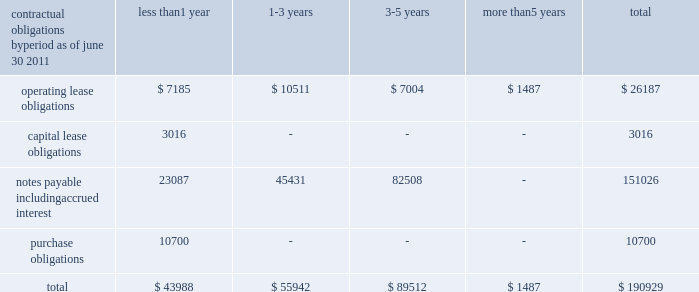Contractual obligations by less than more than period as of june 30 , 2011 1 year 1-3 years 3-5 years 5 years total .
Recent accounting pronouncements in october 2009 , the fasb issued accounting standards update ( 201casu 201d ) no .
2009-13 , multiple-deliverable revenue arrangements , which is effective for arrangements beginning or changed during fiscal years starting after june 15 , 2010 .
This new standard eliminates the use of the residual method of revenue recognition and requires the allocation of consideration to each deliverable using the relative selling price method .
This new guidance did not have a material impact on revenue recognition because nearly all of the company 2019s revenue arrangements are subject to accounting standards codification ( 201casc 201d ) topic 985 .
Such arrangements are considered out of scope for this asu .
In october 2009 , the fasb also issued asu no .
2009-14 , software : certain revenue arrangements that include software elements , which is also effective for arrangements beginning or changed during fiscal years starting after june 15 , 2010 .
This revision to software ( topic 985 ) drops from its scope all tangible products containing both software and non-software components that operate together to deliver the product 2019s functions .
The majority of the company 2019s software arrangements are not tangible products with software components ; therefore , this update did not materially impact the company .
The fasb issued asu no .
2011-04 , fair value measurement in may 2011 , which is effective for the company beginning july 1 , 2012 and is to be applied prospectively .
The updated explanatory guidance on measuring fair value will be adopted by the company at that time and is not expected to have a significant impact on our fair value calculations .
No additional fair value measurements are required as a result of the update .
The fasb also issued asu no .
2011-05 , comprehensive income in june 2011 , which is effective for the company beginning january 1 , 2012 and will be applied retrospectively .
The updated guidance requires non-owner changes in stockholders 2019 equity to be reported either in a single continuous statement of comprehensive income or in two separate but consecutive statements , rather than as part of the statement of changes in stockholders 2019 equity .
No changes in disclosure will be required as a result of the update .
Critical accounting policies we prepare our consolidated financial statements in accordance with accounting principles generally accepted in the united states ( 201cu.s .
Gaap 201d ) .
The significant accounting policies are discussed in note 1 to the consolidated financial statements .
The preparation of consolidated financial statements in accordance with u.s .
Gaap requires us to make estimates and judgments that affect the reported amounts of assets , liabilities , revenue and expenses , as well as disclosure of contingent assets and liabilities .
We base our estimates and judgments upon historical experience and other factors believed to be reasonable under the circumstances .
Changes in estimates or assumptions could result in a material adjustment to the consolidated financial statements .
We have identified several critical accounting estimates .
An accounting estimate is considered critical if both : ( a ) the nature of the estimates or assumptions is material due to the levels of subjectivity and judgment involved , and ( b ) the impact of changes in the estimates and assumptions would have a material effect on the consolidated financial statements. .
What was the percent of the total operating lease obligations that was due in less than 1 year? 
Computations: (7185 / 26187)
Answer: 0.27437. Contractual obligations by less than more than period as of june 30 , 2011 1 year 1-3 years 3-5 years 5 years total .
Recent accounting pronouncements in october 2009 , the fasb issued accounting standards update ( 201casu 201d ) no .
2009-13 , multiple-deliverable revenue arrangements , which is effective for arrangements beginning or changed during fiscal years starting after june 15 , 2010 .
This new standard eliminates the use of the residual method of revenue recognition and requires the allocation of consideration to each deliverable using the relative selling price method .
This new guidance did not have a material impact on revenue recognition because nearly all of the company 2019s revenue arrangements are subject to accounting standards codification ( 201casc 201d ) topic 985 .
Such arrangements are considered out of scope for this asu .
In october 2009 , the fasb also issued asu no .
2009-14 , software : certain revenue arrangements that include software elements , which is also effective for arrangements beginning or changed during fiscal years starting after june 15 , 2010 .
This revision to software ( topic 985 ) drops from its scope all tangible products containing both software and non-software components that operate together to deliver the product 2019s functions .
The majority of the company 2019s software arrangements are not tangible products with software components ; therefore , this update did not materially impact the company .
The fasb issued asu no .
2011-04 , fair value measurement in may 2011 , which is effective for the company beginning july 1 , 2012 and is to be applied prospectively .
The updated explanatory guidance on measuring fair value will be adopted by the company at that time and is not expected to have a significant impact on our fair value calculations .
No additional fair value measurements are required as a result of the update .
The fasb also issued asu no .
2011-05 , comprehensive income in june 2011 , which is effective for the company beginning january 1 , 2012 and will be applied retrospectively .
The updated guidance requires non-owner changes in stockholders 2019 equity to be reported either in a single continuous statement of comprehensive income or in two separate but consecutive statements , rather than as part of the statement of changes in stockholders 2019 equity .
No changes in disclosure will be required as a result of the update .
Critical accounting policies we prepare our consolidated financial statements in accordance with accounting principles generally accepted in the united states ( 201cu.s .
Gaap 201d ) .
The significant accounting policies are discussed in note 1 to the consolidated financial statements .
The preparation of consolidated financial statements in accordance with u.s .
Gaap requires us to make estimates and judgments that affect the reported amounts of assets , liabilities , revenue and expenses , as well as disclosure of contingent assets and liabilities .
We base our estimates and judgments upon historical experience and other factors believed to be reasonable under the circumstances .
Changes in estimates or assumptions could result in a material adjustment to the consolidated financial statements .
We have identified several critical accounting estimates .
An accounting estimate is considered critical if both : ( a ) the nature of the estimates or assumptions is material due to the levels of subjectivity and judgment involved , and ( b ) the impact of changes in the estimates and assumptions would have a material effect on the consolidated financial statements. .
What percent of notes payable including accrued interest is due in less than one year? 
Computations: (23087 / 151026)
Answer: 0.15287. Contractual obligations by less than more than period as of june 30 , 2011 1 year 1-3 years 3-5 years 5 years total .
Recent accounting pronouncements in october 2009 , the fasb issued accounting standards update ( 201casu 201d ) no .
2009-13 , multiple-deliverable revenue arrangements , which is effective for arrangements beginning or changed during fiscal years starting after june 15 , 2010 .
This new standard eliminates the use of the residual method of revenue recognition and requires the allocation of consideration to each deliverable using the relative selling price method .
This new guidance did not have a material impact on revenue recognition because nearly all of the company 2019s revenue arrangements are subject to accounting standards codification ( 201casc 201d ) topic 985 .
Such arrangements are considered out of scope for this asu .
In october 2009 , the fasb also issued asu no .
2009-14 , software : certain revenue arrangements that include software elements , which is also effective for arrangements beginning or changed during fiscal years starting after june 15 , 2010 .
This revision to software ( topic 985 ) drops from its scope all tangible products containing both software and non-software components that operate together to deliver the product 2019s functions .
The majority of the company 2019s software arrangements are not tangible products with software components ; therefore , this update did not materially impact the company .
The fasb issued asu no .
2011-04 , fair value measurement in may 2011 , which is effective for the company beginning july 1 , 2012 and is to be applied prospectively .
The updated explanatory guidance on measuring fair value will be adopted by the company at that time and is not expected to have a significant impact on our fair value calculations .
No additional fair value measurements are required as a result of the update .
The fasb also issued asu no .
2011-05 , comprehensive income in june 2011 , which is effective for the company beginning january 1 , 2012 and will be applied retrospectively .
The updated guidance requires non-owner changes in stockholders 2019 equity to be reported either in a single continuous statement of comprehensive income or in two separate but consecutive statements , rather than as part of the statement of changes in stockholders 2019 equity .
No changes in disclosure will be required as a result of the update .
Critical accounting policies we prepare our consolidated financial statements in accordance with accounting principles generally accepted in the united states ( 201cu.s .
Gaap 201d ) .
The significant accounting policies are discussed in note 1 to the consolidated financial statements .
The preparation of consolidated financial statements in accordance with u.s .
Gaap requires us to make estimates and judgments that affect the reported amounts of assets , liabilities , revenue and expenses , as well as disclosure of contingent assets and liabilities .
We base our estimates and judgments upon historical experience and other factors believed to be reasonable under the circumstances .
Changes in estimates or assumptions could result in a material adjustment to the consolidated financial statements .
We have identified several critical accounting estimates .
An accounting estimate is considered critical if both : ( a ) the nature of the estimates or assumptions is material due to the levels of subjectivity and judgment involved , and ( b ) the impact of changes in the estimates and assumptions would have a material effect on the consolidated financial statements. .
What percent of operating lease obligations are due in less than one year? 
Computations: (7185 / 26187)
Answer: 0.27437. 